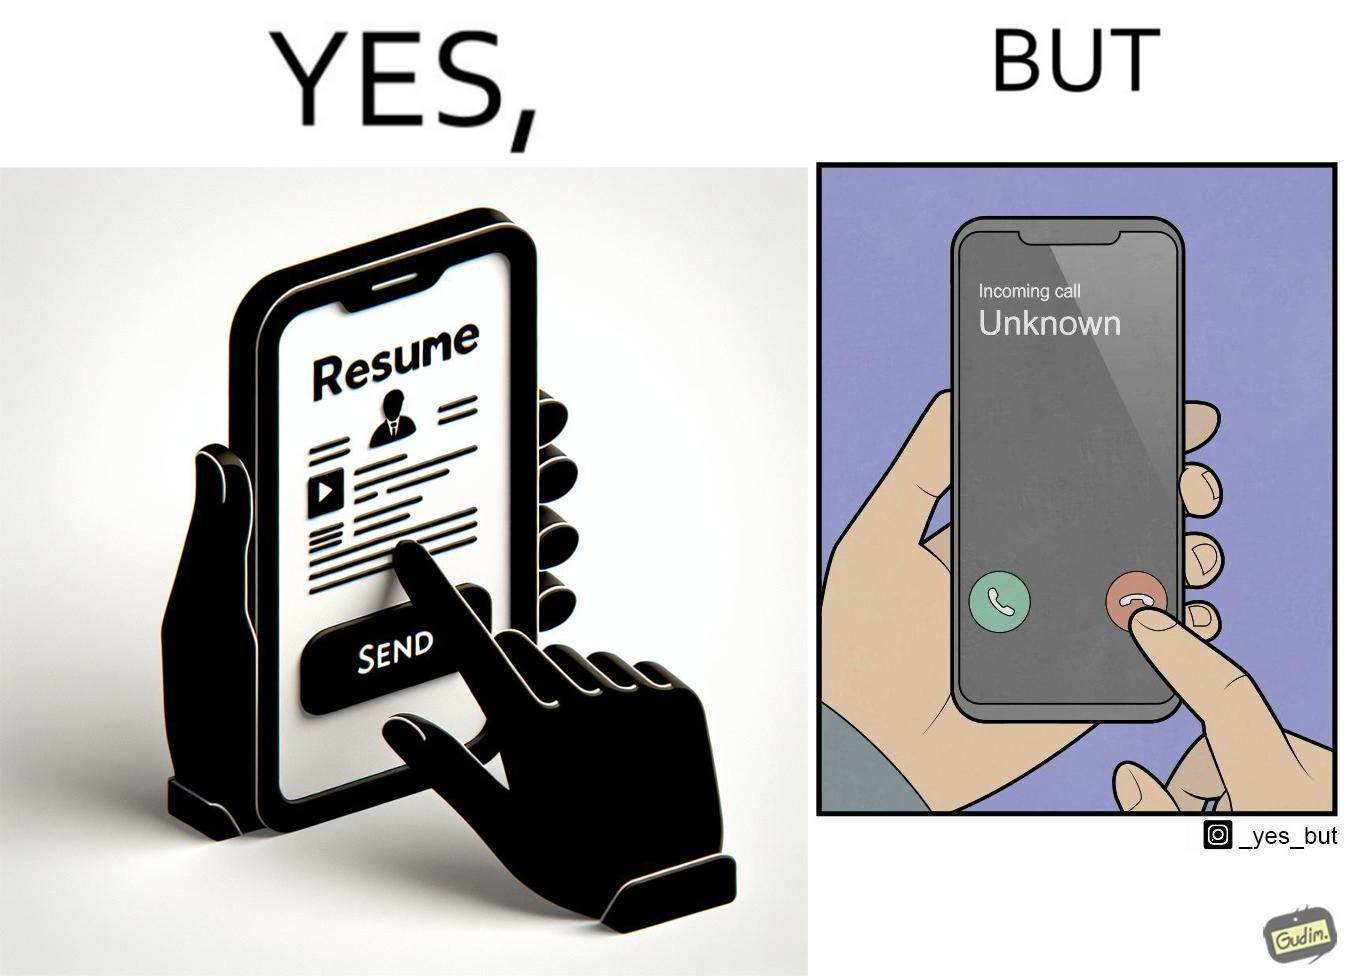Is there satirical content in this image? Yes, this image is satirical. 